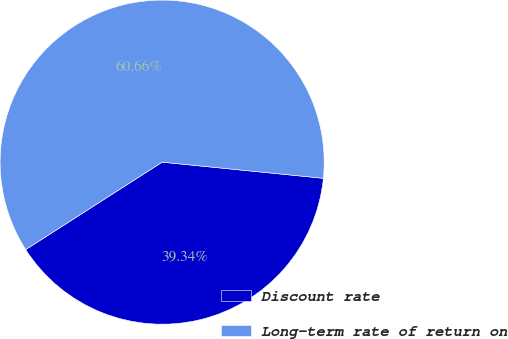<chart> <loc_0><loc_0><loc_500><loc_500><pie_chart><fcel>Discount rate<fcel>Long-term rate of return on<nl><fcel>39.34%<fcel>60.66%<nl></chart> 